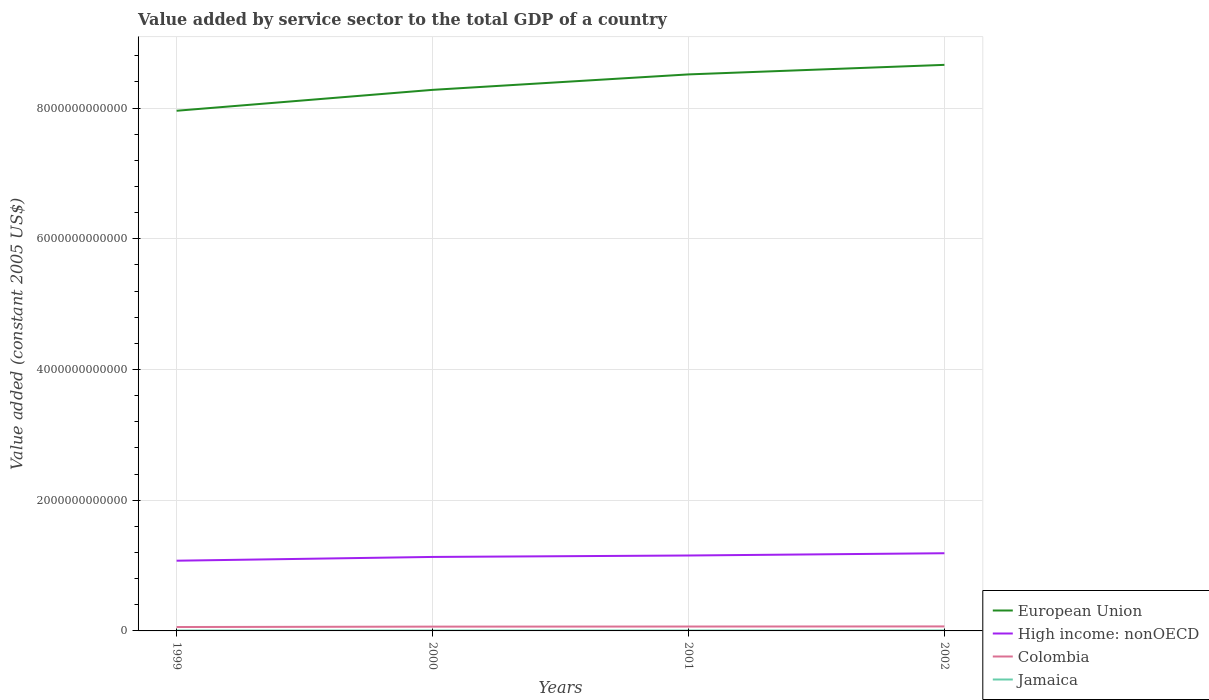Does the line corresponding to European Union intersect with the line corresponding to High income: nonOECD?
Your answer should be very brief. No. Is the number of lines equal to the number of legend labels?
Ensure brevity in your answer.  Yes. Across all years, what is the maximum value added by service sector in European Union?
Your answer should be compact. 7.96e+12. In which year was the value added by service sector in Colombia maximum?
Your response must be concise. 1999. What is the total value added by service sector in European Union in the graph?
Your response must be concise. -1.46e+11. What is the difference between the highest and the second highest value added by service sector in High income: nonOECD?
Ensure brevity in your answer.  1.14e+11. What is the difference between the highest and the lowest value added by service sector in European Union?
Your response must be concise. 2. Is the value added by service sector in High income: nonOECD strictly greater than the value added by service sector in Colombia over the years?
Your response must be concise. No. How many lines are there?
Make the answer very short. 4. What is the difference between two consecutive major ticks on the Y-axis?
Provide a succinct answer. 2.00e+12. Are the values on the major ticks of Y-axis written in scientific E-notation?
Keep it short and to the point. No. Does the graph contain any zero values?
Give a very brief answer. No. Does the graph contain grids?
Your answer should be very brief. Yes. Where does the legend appear in the graph?
Make the answer very short. Bottom right. What is the title of the graph?
Ensure brevity in your answer.  Value added by service sector to the total GDP of a country. What is the label or title of the Y-axis?
Your answer should be compact. Value added (constant 2005 US$). What is the Value added (constant 2005 US$) of European Union in 1999?
Make the answer very short. 7.96e+12. What is the Value added (constant 2005 US$) of High income: nonOECD in 1999?
Your answer should be compact. 1.07e+12. What is the Value added (constant 2005 US$) in Colombia in 1999?
Make the answer very short. 5.97e+1. What is the Value added (constant 2005 US$) of Jamaica in 1999?
Provide a short and direct response. 5.97e+09. What is the Value added (constant 2005 US$) in European Union in 2000?
Offer a very short reply. 8.28e+12. What is the Value added (constant 2005 US$) of High income: nonOECD in 2000?
Provide a short and direct response. 1.13e+12. What is the Value added (constant 2005 US$) in Colombia in 2000?
Your answer should be compact. 6.58e+1. What is the Value added (constant 2005 US$) of Jamaica in 2000?
Your response must be concise. 6.14e+09. What is the Value added (constant 2005 US$) in European Union in 2001?
Provide a succinct answer. 8.51e+12. What is the Value added (constant 2005 US$) of High income: nonOECD in 2001?
Make the answer very short. 1.15e+12. What is the Value added (constant 2005 US$) of Colombia in 2001?
Ensure brevity in your answer.  6.72e+1. What is the Value added (constant 2005 US$) in Jamaica in 2001?
Make the answer very short. 6.22e+09. What is the Value added (constant 2005 US$) of European Union in 2002?
Give a very brief answer. 8.66e+12. What is the Value added (constant 2005 US$) in High income: nonOECD in 2002?
Keep it short and to the point. 1.19e+12. What is the Value added (constant 2005 US$) of Colombia in 2002?
Provide a succinct answer. 6.89e+1. What is the Value added (constant 2005 US$) of Jamaica in 2002?
Provide a succinct answer. 6.33e+09. Across all years, what is the maximum Value added (constant 2005 US$) in European Union?
Give a very brief answer. 8.66e+12. Across all years, what is the maximum Value added (constant 2005 US$) in High income: nonOECD?
Your answer should be compact. 1.19e+12. Across all years, what is the maximum Value added (constant 2005 US$) in Colombia?
Give a very brief answer. 6.89e+1. Across all years, what is the maximum Value added (constant 2005 US$) of Jamaica?
Your response must be concise. 6.33e+09. Across all years, what is the minimum Value added (constant 2005 US$) of European Union?
Offer a terse response. 7.96e+12. Across all years, what is the minimum Value added (constant 2005 US$) of High income: nonOECD?
Ensure brevity in your answer.  1.07e+12. Across all years, what is the minimum Value added (constant 2005 US$) of Colombia?
Keep it short and to the point. 5.97e+1. Across all years, what is the minimum Value added (constant 2005 US$) of Jamaica?
Provide a succinct answer. 5.97e+09. What is the total Value added (constant 2005 US$) in European Union in the graph?
Give a very brief answer. 3.34e+13. What is the total Value added (constant 2005 US$) of High income: nonOECD in the graph?
Offer a terse response. 4.55e+12. What is the total Value added (constant 2005 US$) in Colombia in the graph?
Offer a terse response. 2.62e+11. What is the total Value added (constant 2005 US$) in Jamaica in the graph?
Offer a very short reply. 2.47e+1. What is the difference between the Value added (constant 2005 US$) of European Union in 1999 and that in 2000?
Give a very brief answer. -3.20e+11. What is the difference between the Value added (constant 2005 US$) in High income: nonOECD in 1999 and that in 2000?
Keep it short and to the point. -5.76e+1. What is the difference between the Value added (constant 2005 US$) in Colombia in 1999 and that in 2000?
Offer a very short reply. -6.11e+09. What is the difference between the Value added (constant 2005 US$) of Jamaica in 1999 and that in 2000?
Keep it short and to the point. -1.65e+08. What is the difference between the Value added (constant 2005 US$) in European Union in 1999 and that in 2001?
Your answer should be compact. -5.56e+11. What is the difference between the Value added (constant 2005 US$) of High income: nonOECD in 1999 and that in 2001?
Provide a succinct answer. -7.97e+1. What is the difference between the Value added (constant 2005 US$) of Colombia in 1999 and that in 2001?
Offer a very short reply. -7.53e+09. What is the difference between the Value added (constant 2005 US$) in Jamaica in 1999 and that in 2001?
Ensure brevity in your answer.  -2.46e+08. What is the difference between the Value added (constant 2005 US$) of European Union in 1999 and that in 2002?
Your response must be concise. -7.02e+11. What is the difference between the Value added (constant 2005 US$) in High income: nonOECD in 1999 and that in 2002?
Provide a short and direct response. -1.14e+11. What is the difference between the Value added (constant 2005 US$) in Colombia in 1999 and that in 2002?
Your response must be concise. -9.19e+09. What is the difference between the Value added (constant 2005 US$) of Jamaica in 1999 and that in 2002?
Your answer should be compact. -3.59e+08. What is the difference between the Value added (constant 2005 US$) of European Union in 2000 and that in 2001?
Offer a very short reply. -2.36e+11. What is the difference between the Value added (constant 2005 US$) in High income: nonOECD in 2000 and that in 2001?
Make the answer very short. -2.20e+1. What is the difference between the Value added (constant 2005 US$) in Colombia in 2000 and that in 2001?
Provide a short and direct response. -1.42e+09. What is the difference between the Value added (constant 2005 US$) of Jamaica in 2000 and that in 2001?
Provide a succinct answer. -8.12e+07. What is the difference between the Value added (constant 2005 US$) of European Union in 2000 and that in 2002?
Offer a very short reply. -3.82e+11. What is the difference between the Value added (constant 2005 US$) in High income: nonOECD in 2000 and that in 2002?
Offer a terse response. -5.66e+1. What is the difference between the Value added (constant 2005 US$) in Colombia in 2000 and that in 2002?
Keep it short and to the point. -3.07e+09. What is the difference between the Value added (constant 2005 US$) of Jamaica in 2000 and that in 2002?
Ensure brevity in your answer.  -1.94e+08. What is the difference between the Value added (constant 2005 US$) in European Union in 2001 and that in 2002?
Offer a very short reply. -1.46e+11. What is the difference between the Value added (constant 2005 US$) of High income: nonOECD in 2001 and that in 2002?
Your response must be concise. -3.46e+1. What is the difference between the Value added (constant 2005 US$) of Colombia in 2001 and that in 2002?
Your answer should be compact. -1.65e+09. What is the difference between the Value added (constant 2005 US$) in Jamaica in 2001 and that in 2002?
Your response must be concise. -1.13e+08. What is the difference between the Value added (constant 2005 US$) in European Union in 1999 and the Value added (constant 2005 US$) in High income: nonOECD in 2000?
Your answer should be very brief. 6.83e+12. What is the difference between the Value added (constant 2005 US$) of European Union in 1999 and the Value added (constant 2005 US$) of Colombia in 2000?
Offer a terse response. 7.89e+12. What is the difference between the Value added (constant 2005 US$) in European Union in 1999 and the Value added (constant 2005 US$) in Jamaica in 2000?
Keep it short and to the point. 7.95e+12. What is the difference between the Value added (constant 2005 US$) of High income: nonOECD in 1999 and the Value added (constant 2005 US$) of Colombia in 2000?
Provide a succinct answer. 1.01e+12. What is the difference between the Value added (constant 2005 US$) of High income: nonOECD in 1999 and the Value added (constant 2005 US$) of Jamaica in 2000?
Offer a terse response. 1.07e+12. What is the difference between the Value added (constant 2005 US$) of Colombia in 1999 and the Value added (constant 2005 US$) of Jamaica in 2000?
Keep it short and to the point. 5.35e+1. What is the difference between the Value added (constant 2005 US$) in European Union in 1999 and the Value added (constant 2005 US$) in High income: nonOECD in 2001?
Provide a short and direct response. 6.80e+12. What is the difference between the Value added (constant 2005 US$) in European Union in 1999 and the Value added (constant 2005 US$) in Colombia in 2001?
Keep it short and to the point. 7.89e+12. What is the difference between the Value added (constant 2005 US$) of European Union in 1999 and the Value added (constant 2005 US$) of Jamaica in 2001?
Ensure brevity in your answer.  7.95e+12. What is the difference between the Value added (constant 2005 US$) of High income: nonOECD in 1999 and the Value added (constant 2005 US$) of Colombia in 2001?
Offer a terse response. 1.01e+12. What is the difference between the Value added (constant 2005 US$) in High income: nonOECD in 1999 and the Value added (constant 2005 US$) in Jamaica in 2001?
Offer a very short reply. 1.07e+12. What is the difference between the Value added (constant 2005 US$) of Colombia in 1999 and the Value added (constant 2005 US$) of Jamaica in 2001?
Your answer should be very brief. 5.35e+1. What is the difference between the Value added (constant 2005 US$) of European Union in 1999 and the Value added (constant 2005 US$) of High income: nonOECD in 2002?
Provide a short and direct response. 6.77e+12. What is the difference between the Value added (constant 2005 US$) of European Union in 1999 and the Value added (constant 2005 US$) of Colombia in 2002?
Ensure brevity in your answer.  7.89e+12. What is the difference between the Value added (constant 2005 US$) in European Union in 1999 and the Value added (constant 2005 US$) in Jamaica in 2002?
Ensure brevity in your answer.  7.95e+12. What is the difference between the Value added (constant 2005 US$) of High income: nonOECD in 1999 and the Value added (constant 2005 US$) of Colombia in 2002?
Provide a succinct answer. 1.01e+12. What is the difference between the Value added (constant 2005 US$) in High income: nonOECD in 1999 and the Value added (constant 2005 US$) in Jamaica in 2002?
Your response must be concise. 1.07e+12. What is the difference between the Value added (constant 2005 US$) of Colombia in 1999 and the Value added (constant 2005 US$) of Jamaica in 2002?
Your response must be concise. 5.34e+1. What is the difference between the Value added (constant 2005 US$) of European Union in 2000 and the Value added (constant 2005 US$) of High income: nonOECD in 2001?
Keep it short and to the point. 7.12e+12. What is the difference between the Value added (constant 2005 US$) of European Union in 2000 and the Value added (constant 2005 US$) of Colombia in 2001?
Offer a terse response. 8.21e+12. What is the difference between the Value added (constant 2005 US$) in European Union in 2000 and the Value added (constant 2005 US$) in Jamaica in 2001?
Provide a short and direct response. 8.27e+12. What is the difference between the Value added (constant 2005 US$) of High income: nonOECD in 2000 and the Value added (constant 2005 US$) of Colombia in 2001?
Offer a terse response. 1.06e+12. What is the difference between the Value added (constant 2005 US$) of High income: nonOECD in 2000 and the Value added (constant 2005 US$) of Jamaica in 2001?
Offer a very short reply. 1.13e+12. What is the difference between the Value added (constant 2005 US$) of Colombia in 2000 and the Value added (constant 2005 US$) of Jamaica in 2001?
Make the answer very short. 5.96e+1. What is the difference between the Value added (constant 2005 US$) in European Union in 2000 and the Value added (constant 2005 US$) in High income: nonOECD in 2002?
Provide a succinct answer. 7.09e+12. What is the difference between the Value added (constant 2005 US$) of European Union in 2000 and the Value added (constant 2005 US$) of Colombia in 2002?
Keep it short and to the point. 8.21e+12. What is the difference between the Value added (constant 2005 US$) in European Union in 2000 and the Value added (constant 2005 US$) in Jamaica in 2002?
Offer a very short reply. 8.27e+12. What is the difference between the Value added (constant 2005 US$) of High income: nonOECD in 2000 and the Value added (constant 2005 US$) of Colombia in 2002?
Make the answer very short. 1.06e+12. What is the difference between the Value added (constant 2005 US$) of High income: nonOECD in 2000 and the Value added (constant 2005 US$) of Jamaica in 2002?
Offer a terse response. 1.13e+12. What is the difference between the Value added (constant 2005 US$) of Colombia in 2000 and the Value added (constant 2005 US$) of Jamaica in 2002?
Your answer should be compact. 5.95e+1. What is the difference between the Value added (constant 2005 US$) of European Union in 2001 and the Value added (constant 2005 US$) of High income: nonOECD in 2002?
Offer a very short reply. 7.33e+12. What is the difference between the Value added (constant 2005 US$) of European Union in 2001 and the Value added (constant 2005 US$) of Colombia in 2002?
Keep it short and to the point. 8.45e+12. What is the difference between the Value added (constant 2005 US$) of European Union in 2001 and the Value added (constant 2005 US$) of Jamaica in 2002?
Make the answer very short. 8.51e+12. What is the difference between the Value added (constant 2005 US$) in High income: nonOECD in 2001 and the Value added (constant 2005 US$) in Colombia in 2002?
Offer a very short reply. 1.09e+12. What is the difference between the Value added (constant 2005 US$) of High income: nonOECD in 2001 and the Value added (constant 2005 US$) of Jamaica in 2002?
Your answer should be very brief. 1.15e+12. What is the difference between the Value added (constant 2005 US$) of Colombia in 2001 and the Value added (constant 2005 US$) of Jamaica in 2002?
Your answer should be very brief. 6.09e+1. What is the average Value added (constant 2005 US$) in European Union per year?
Provide a short and direct response. 8.35e+12. What is the average Value added (constant 2005 US$) in High income: nonOECD per year?
Your answer should be compact. 1.14e+12. What is the average Value added (constant 2005 US$) of Colombia per year?
Keep it short and to the point. 6.54e+1. What is the average Value added (constant 2005 US$) of Jamaica per year?
Your response must be concise. 6.16e+09. In the year 1999, what is the difference between the Value added (constant 2005 US$) in European Union and Value added (constant 2005 US$) in High income: nonOECD?
Keep it short and to the point. 6.88e+12. In the year 1999, what is the difference between the Value added (constant 2005 US$) of European Union and Value added (constant 2005 US$) of Colombia?
Your answer should be very brief. 7.90e+12. In the year 1999, what is the difference between the Value added (constant 2005 US$) of European Union and Value added (constant 2005 US$) of Jamaica?
Offer a very short reply. 7.95e+12. In the year 1999, what is the difference between the Value added (constant 2005 US$) of High income: nonOECD and Value added (constant 2005 US$) of Colombia?
Provide a succinct answer. 1.01e+12. In the year 1999, what is the difference between the Value added (constant 2005 US$) of High income: nonOECD and Value added (constant 2005 US$) of Jamaica?
Provide a succinct answer. 1.07e+12. In the year 1999, what is the difference between the Value added (constant 2005 US$) in Colombia and Value added (constant 2005 US$) in Jamaica?
Provide a short and direct response. 5.37e+1. In the year 2000, what is the difference between the Value added (constant 2005 US$) of European Union and Value added (constant 2005 US$) of High income: nonOECD?
Give a very brief answer. 7.15e+12. In the year 2000, what is the difference between the Value added (constant 2005 US$) in European Union and Value added (constant 2005 US$) in Colombia?
Keep it short and to the point. 8.21e+12. In the year 2000, what is the difference between the Value added (constant 2005 US$) in European Union and Value added (constant 2005 US$) in Jamaica?
Offer a terse response. 8.27e+12. In the year 2000, what is the difference between the Value added (constant 2005 US$) in High income: nonOECD and Value added (constant 2005 US$) in Colombia?
Your answer should be compact. 1.07e+12. In the year 2000, what is the difference between the Value added (constant 2005 US$) of High income: nonOECD and Value added (constant 2005 US$) of Jamaica?
Provide a short and direct response. 1.13e+12. In the year 2000, what is the difference between the Value added (constant 2005 US$) in Colombia and Value added (constant 2005 US$) in Jamaica?
Your answer should be compact. 5.97e+1. In the year 2001, what is the difference between the Value added (constant 2005 US$) of European Union and Value added (constant 2005 US$) of High income: nonOECD?
Make the answer very short. 7.36e+12. In the year 2001, what is the difference between the Value added (constant 2005 US$) in European Union and Value added (constant 2005 US$) in Colombia?
Ensure brevity in your answer.  8.45e+12. In the year 2001, what is the difference between the Value added (constant 2005 US$) of European Union and Value added (constant 2005 US$) of Jamaica?
Ensure brevity in your answer.  8.51e+12. In the year 2001, what is the difference between the Value added (constant 2005 US$) in High income: nonOECD and Value added (constant 2005 US$) in Colombia?
Your response must be concise. 1.09e+12. In the year 2001, what is the difference between the Value added (constant 2005 US$) of High income: nonOECD and Value added (constant 2005 US$) of Jamaica?
Give a very brief answer. 1.15e+12. In the year 2001, what is the difference between the Value added (constant 2005 US$) of Colombia and Value added (constant 2005 US$) of Jamaica?
Provide a succinct answer. 6.10e+1. In the year 2002, what is the difference between the Value added (constant 2005 US$) in European Union and Value added (constant 2005 US$) in High income: nonOECD?
Provide a succinct answer. 7.47e+12. In the year 2002, what is the difference between the Value added (constant 2005 US$) in European Union and Value added (constant 2005 US$) in Colombia?
Your answer should be very brief. 8.59e+12. In the year 2002, what is the difference between the Value added (constant 2005 US$) in European Union and Value added (constant 2005 US$) in Jamaica?
Your response must be concise. 8.65e+12. In the year 2002, what is the difference between the Value added (constant 2005 US$) in High income: nonOECD and Value added (constant 2005 US$) in Colombia?
Your answer should be very brief. 1.12e+12. In the year 2002, what is the difference between the Value added (constant 2005 US$) in High income: nonOECD and Value added (constant 2005 US$) in Jamaica?
Offer a very short reply. 1.18e+12. In the year 2002, what is the difference between the Value added (constant 2005 US$) in Colombia and Value added (constant 2005 US$) in Jamaica?
Give a very brief answer. 6.25e+1. What is the ratio of the Value added (constant 2005 US$) in European Union in 1999 to that in 2000?
Your response must be concise. 0.96. What is the ratio of the Value added (constant 2005 US$) in High income: nonOECD in 1999 to that in 2000?
Your answer should be compact. 0.95. What is the ratio of the Value added (constant 2005 US$) of Colombia in 1999 to that in 2000?
Your answer should be compact. 0.91. What is the ratio of the Value added (constant 2005 US$) of Jamaica in 1999 to that in 2000?
Your answer should be compact. 0.97. What is the ratio of the Value added (constant 2005 US$) of European Union in 1999 to that in 2001?
Offer a very short reply. 0.93. What is the ratio of the Value added (constant 2005 US$) of High income: nonOECD in 1999 to that in 2001?
Your response must be concise. 0.93. What is the ratio of the Value added (constant 2005 US$) of Colombia in 1999 to that in 2001?
Offer a very short reply. 0.89. What is the ratio of the Value added (constant 2005 US$) of Jamaica in 1999 to that in 2001?
Make the answer very short. 0.96. What is the ratio of the Value added (constant 2005 US$) of European Union in 1999 to that in 2002?
Your response must be concise. 0.92. What is the ratio of the Value added (constant 2005 US$) in High income: nonOECD in 1999 to that in 2002?
Offer a terse response. 0.9. What is the ratio of the Value added (constant 2005 US$) of Colombia in 1999 to that in 2002?
Offer a terse response. 0.87. What is the ratio of the Value added (constant 2005 US$) in Jamaica in 1999 to that in 2002?
Give a very brief answer. 0.94. What is the ratio of the Value added (constant 2005 US$) in European Union in 2000 to that in 2001?
Your answer should be compact. 0.97. What is the ratio of the Value added (constant 2005 US$) in High income: nonOECD in 2000 to that in 2001?
Your answer should be very brief. 0.98. What is the ratio of the Value added (constant 2005 US$) of Colombia in 2000 to that in 2001?
Your answer should be very brief. 0.98. What is the ratio of the Value added (constant 2005 US$) in Jamaica in 2000 to that in 2001?
Offer a very short reply. 0.99. What is the ratio of the Value added (constant 2005 US$) of European Union in 2000 to that in 2002?
Keep it short and to the point. 0.96. What is the ratio of the Value added (constant 2005 US$) of High income: nonOECD in 2000 to that in 2002?
Provide a succinct answer. 0.95. What is the ratio of the Value added (constant 2005 US$) of Colombia in 2000 to that in 2002?
Provide a succinct answer. 0.96. What is the ratio of the Value added (constant 2005 US$) in Jamaica in 2000 to that in 2002?
Provide a short and direct response. 0.97. What is the ratio of the Value added (constant 2005 US$) of European Union in 2001 to that in 2002?
Provide a short and direct response. 0.98. What is the ratio of the Value added (constant 2005 US$) of High income: nonOECD in 2001 to that in 2002?
Give a very brief answer. 0.97. What is the ratio of the Value added (constant 2005 US$) in Colombia in 2001 to that in 2002?
Keep it short and to the point. 0.98. What is the ratio of the Value added (constant 2005 US$) in Jamaica in 2001 to that in 2002?
Your answer should be very brief. 0.98. What is the difference between the highest and the second highest Value added (constant 2005 US$) of European Union?
Give a very brief answer. 1.46e+11. What is the difference between the highest and the second highest Value added (constant 2005 US$) in High income: nonOECD?
Offer a very short reply. 3.46e+1. What is the difference between the highest and the second highest Value added (constant 2005 US$) of Colombia?
Your response must be concise. 1.65e+09. What is the difference between the highest and the second highest Value added (constant 2005 US$) of Jamaica?
Keep it short and to the point. 1.13e+08. What is the difference between the highest and the lowest Value added (constant 2005 US$) in European Union?
Provide a short and direct response. 7.02e+11. What is the difference between the highest and the lowest Value added (constant 2005 US$) in High income: nonOECD?
Give a very brief answer. 1.14e+11. What is the difference between the highest and the lowest Value added (constant 2005 US$) of Colombia?
Offer a terse response. 9.19e+09. What is the difference between the highest and the lowest Value added (constant 2005 US$) in Jamaica?
Keep it short and to the point. 3.59e+08. 